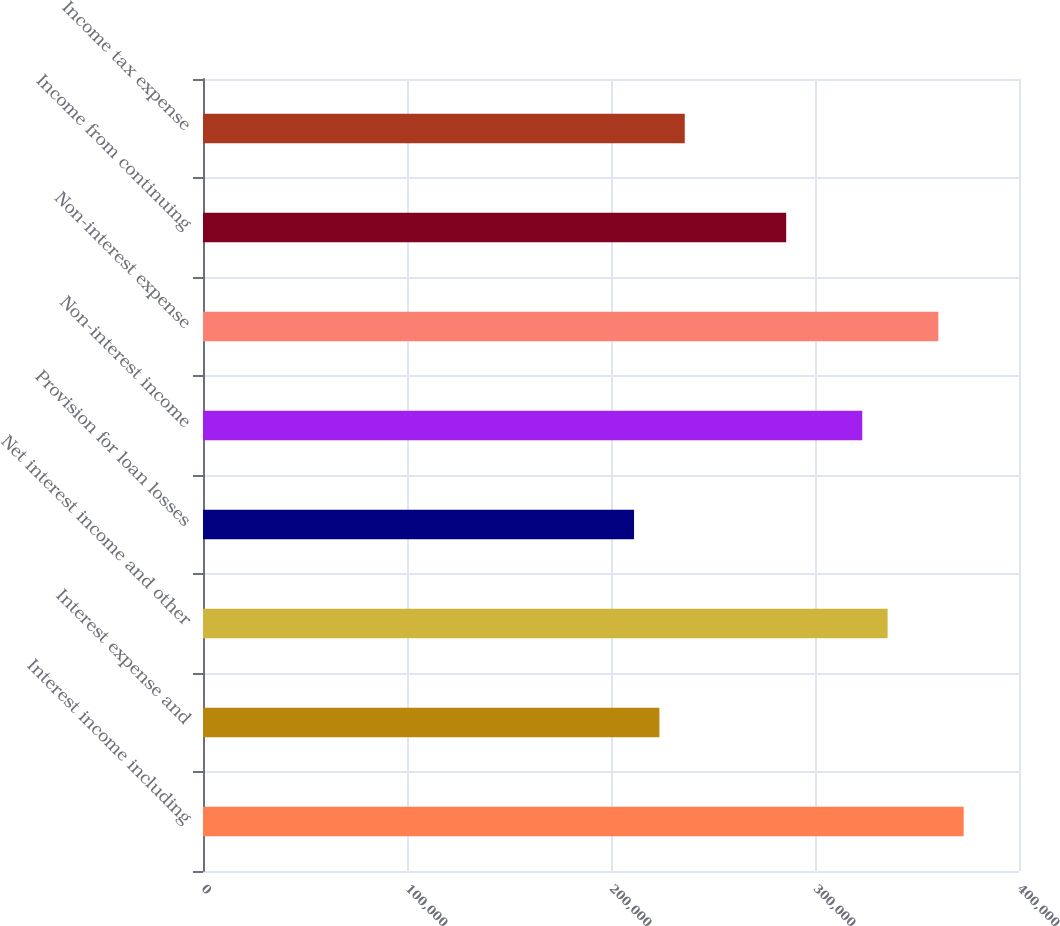Convert chart. <chart><loc_0><loc_0><loc_500><loc_500><bar_chart><fcel>Interest income including<fcel>Interest expense and<fcel>Net interest income and other<fcel>Provision for loan losses<fcel>Non-interest income<fcel>Non-interest expense<fcel>Income from continuing<fcel>Income tax expense<nl><fcel>372880<fcel>223728<fcel>335592<fcel>211299<fcel>323163<fcel>360451<fcel>285875<fcel>236158<nl></chart> 